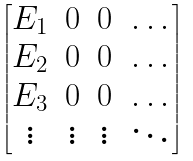<formula> <loc_0><loc_0><loc_500><loc_500>\begin{bmatrix} E _ { 1 } & 0 & 0 & \dots \\ E _ { 2 } & 0 & 0 & \dots \\ E _ { 3 } & 0 & 0 & \dots \\ \vdots & \vdots & \vdots & \ddots \end{bmatrix}</formula> 